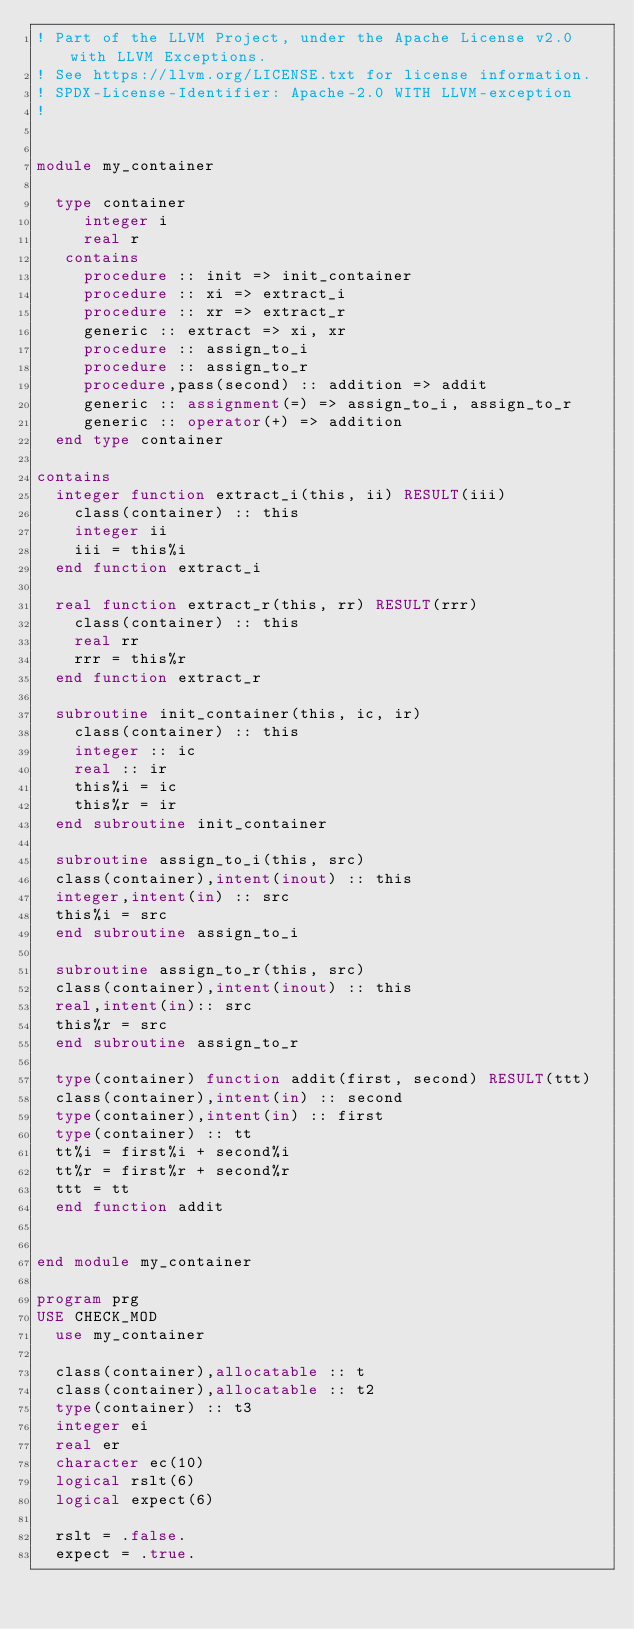Convert code to text. <code><loc_0><loc_0><loc_500><loc_500><_FORTRAN_>! Part of the LLVM Project, under the Apache License v2.0 with LLVM Exceptions.
! See https://llvm.org/LICENSE.txt for license information.
! SPDX-License-Identifier: Apache-2.0 WITH LLVM-exception
!       


module my_container
  
  type container
     integer i
     real r
   contains
     procedure :: init => init_container
     procedure :: xi => extract_i
     procedure :: xr => extract_r
     generic :: extract => xi, xr
     procedure :: assign_to_i 
     procedure :: assign_to_r
     procedure,pass(second) :: addition => addit
     generic :: assignment(=) => assign_to_i, assign_to_r
     generic :: operator(+) => addition
  end type container

contains
  integer function extract_i(this, ii) RESULT(iii)
    class(container) :: this
    integer ii
    iii = this%i
  end function extract_i
  
  real function extract_r(this, rr) RESULT(rrr)
    class(container) :: this
    real rr
    rrr = this%r
  end function extract_r

  subroutine init_container(this, ic, ir)
    class(container) :: this
    integer :: ic
    real :: ir
    this%i = ic
    this%r = ir
  end subroutine init_container

  subroutine assign_to_i(this, src)
  class(container),intent(inout) :: this
  integer,intent(in) :: src
  this%i = src
  end subroutine assign_to_i

  subroutine assign_to_r(this, src)
  class(container),intent(inout) :: this
  real,intent(in):: src
  this%r = src
  end subroutine assign_to_r

  type(container) function addit(first, second) RESULT(ttt)
  class(container),intent(in) :: second
  type(container),intent(in) :: first
  type(container) :: tt
  tt%i = first%i + second%i
  tt%r = first%r + second%r
  ttt = tt
  end function addit


end module my_container

program prg
USE CHECK_MOD
  use my_container

  class(container),allocatable :: t
  class(container),allocatable :: t2
  type(container) :: t3
  integer ei
  real er
  character ec(10)
  logical rslt(6)
  logical expect(6)
  
  rslt = .false.
  expect = .true.</code> 